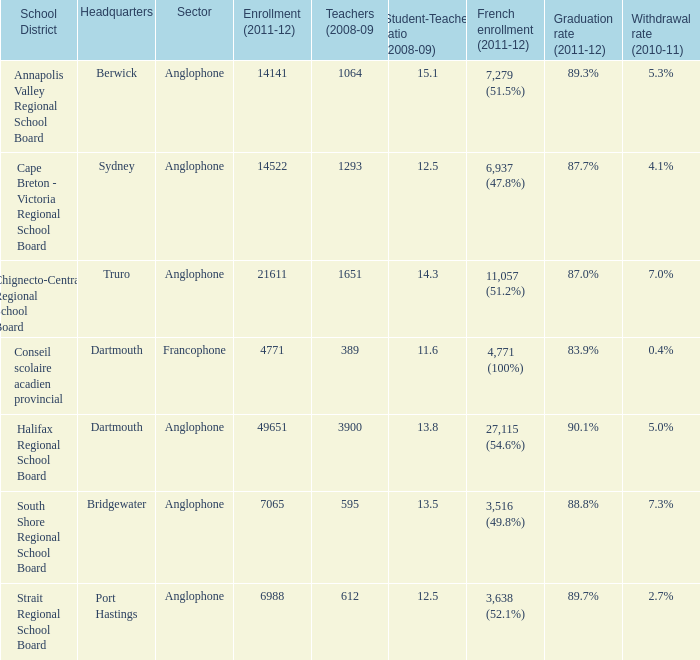What is the location of the principal office for the annapolis valley regional school board? Berwick. 